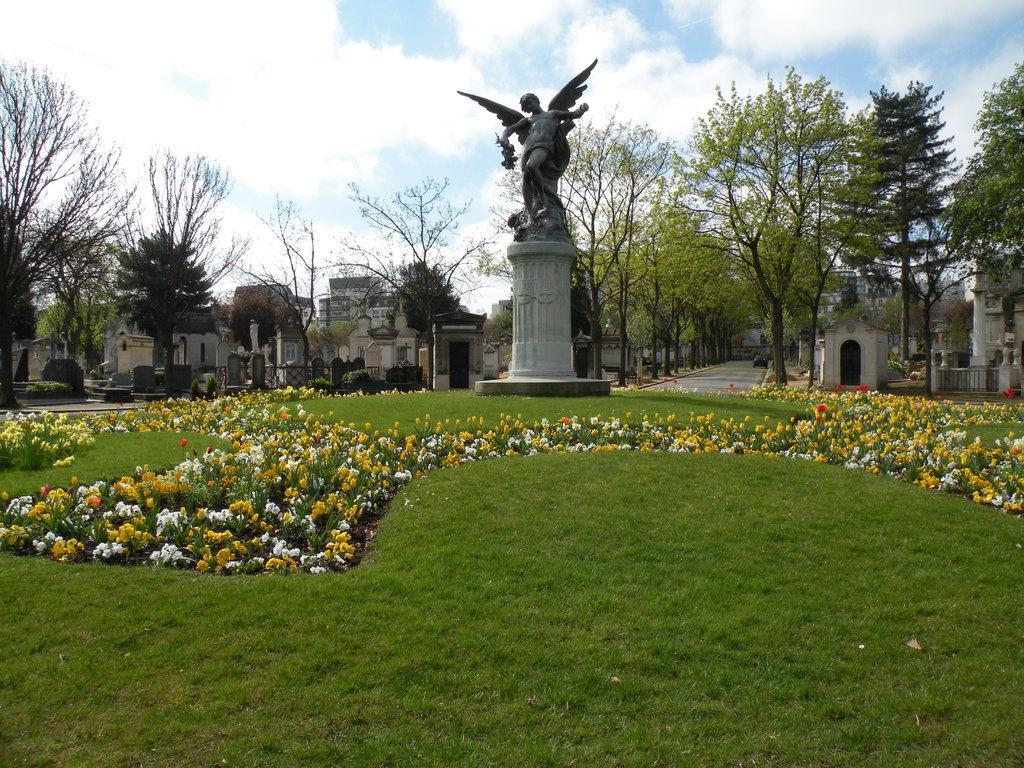Could you give a brief overview of what you see in this image? In this image we can see a statue on a pedestal. On the ground there is grass and flowering plants. In the background there are trees and buildings. Also there is a road. And there is sky with clouds. 